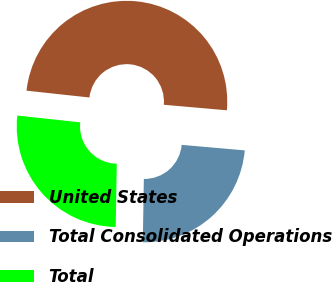<chart> <loc_0><loc_0><loc_500><loc_500><pie_chart><fcel>United States<fcel>Total Consolidated Operations<fcel>Total<nl><fcel>49.68%<fcel>23.87%<fcel>26.45%<nl></chart> 